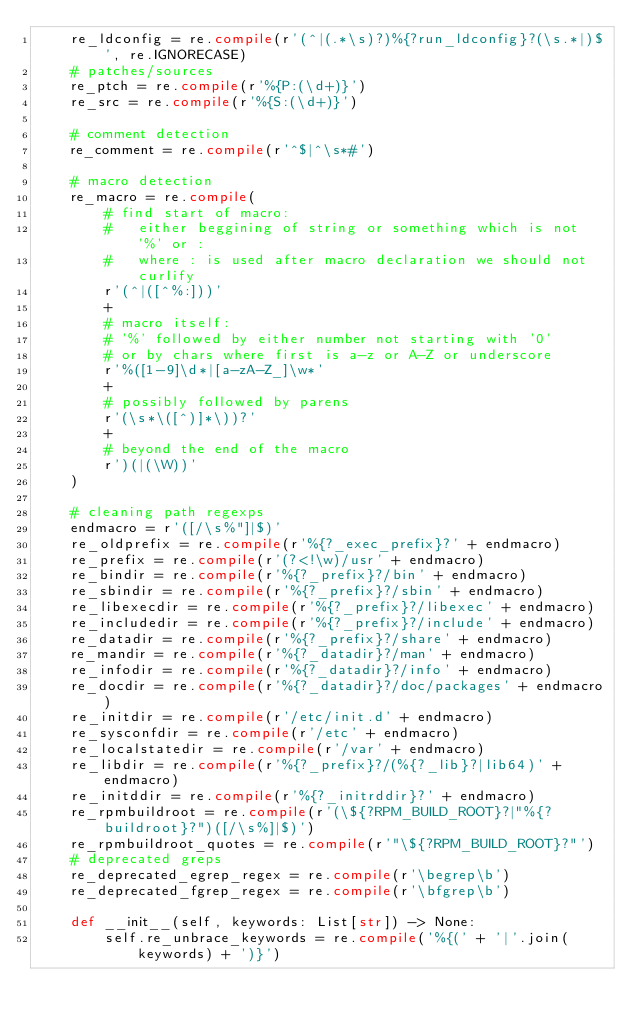<code> <loc_0><loc_0><loc_500><loc_500><_Python_>    re_ldconfig = re.compile(r'(^|(.*\s)?)%{?run_ldconfig}?(\s.*|)$', re.IGNORECASE)
    # patches/sources
    re_ptch = re.compile(r'%{P:(\d+)}')
    re_src = re.compile(r'%{S:(\d+)}')

    # comment detection
    re_comment = re.compile(r'^$|^\s*#')

    # macro detection
    re_macro = re.compile(
        # find start of macro:
        #   either beggining of string or something which is not '%' or :
        #   where : is used after macro declaration we should not curlify
        r'(^|([^%:]))'
        +
        # macro itself:
        # '%' followed by either number not starting with '0'
        # or by chars where first is a-z or A-Z or underscore
        r'%([1-9]\d*|[a-zA-Z_]\w*'
        +
        # possibly followed by parens
        r'(\s*\([^)]*\))?'
        +
        # beyond the end of the macro
        r')(|(\W))'
    )

    # cleaning path regexps
    endmacro = r'([/\s%"]|$)'
    re_oldprefix = re.compile(r'%{?_exec_prefix}?' + endmacro)
    re_prefix = re.compile(r'(?<!\w)/usr' + endmacro)
    re_bindir = re.compile(r'%{?_prefix}?/bin' + endmacro)
    re_sbindir = re.compile(r'%{?_prefix}?/sbin' + endmacro)
    re_libexecdir = re.compile(r'%{?_prefix}?/libexec' + endmacro)
    re_includedir = re.compile(r'%{?_prefix}?/include' + endmacro)
    re_datadir = re.compile(r'%{?_prefix}?/share' + endmacro)
    re_mandir = re.compile(r'%{?_datadir}?/man' + endmacro)
    re_infodir = re.compile(r'%{?_datadir}?/info' + endmacro)
    re_docdir = re.compile(r'%{?_datadir}?/doc/packages' + endmacro)
    re_initdir = re.compile(r'/etc/init.d' + endmacro)
    re_sysconfdir = re.compile(r'/etc' + endmacro)
    re_localstatedir = re.compile(r'/var' + endmacro)
    re_libdir = re.compile(r'%{?_prefix}?/(%{?_lib}?|lib64)' + endmacro)
    re_initddir = re.compile(r'%{?_initrddir}?' + endmacro)
    re_rpmbuildroot = re.compile(r'(\${?RPM_BUILD_ROOT}?|"%{?buildroot}?")([/\s%]|$)')
    re_rpmbuildroot_quotes = re.compile(r'"\${?RPM_BUILD_ROOT}?"')
    # deprecated greps
    re_deprecated_egrep_regex = re.compile(r'\begrep\b')
    re_deprecated_fgrep_regex = re.compile(r'\bfgrep\b')

    def __init__(self, keywords: List[str]) -> None:
        self.re_unbrace_keywords = re.compile('%{(' + '|'.join(keywords) + ')}')
</code> 